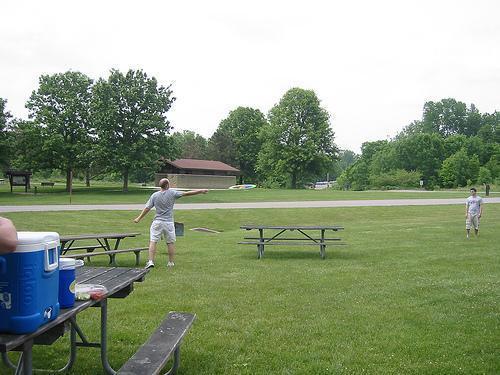How many people are there?
Give a very brief answer. 2. 